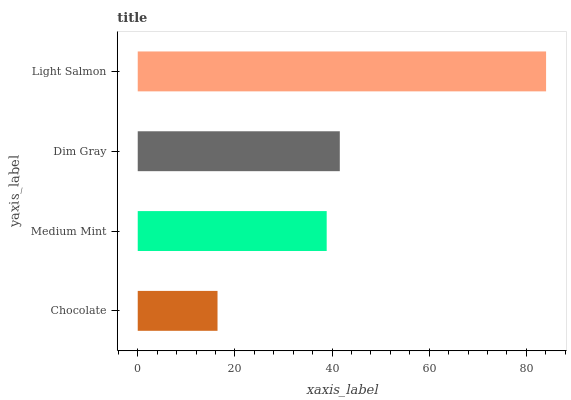Is Chocolate the minimum?
Answer yes or no. Yes. Is Light Salmon the maximum?
Answer yes or no. Yes. Is Medium Mint the minimum?
Answer yes or no. No. Is Medium Mint the maximum?
Answer yes or no. No. Is Medium Mint greater than Chocolate?
Answer yes or no. Yes. Is Chocolate less than Medium Mint?
Answer yes or no. Yes. Is Chocolate greater than Medium Mint?
Answer yes or no. No. Is Medium Mint less than Chocolate?
Answer yes or no. No. Is Dim Gray the high median?
Answer yes or no. Yes. Is Medium Mint the low median?
Answer yes or no. Yes. Is Medium Mint the high median?
Answer yes or no. No. Is Dim Gray the low median?
Answer yes or no. No. 